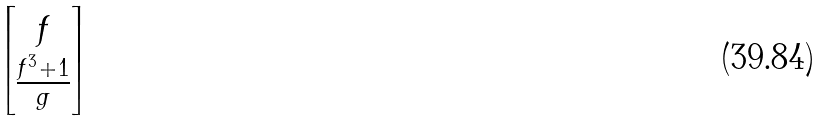<formula> <loc_0><loc_0><loc_500><loc_500>\begin{bmatrix} f \\ \frac { f ^ { 3 } + 1 } { g } \end{bmatrix}</formula> 